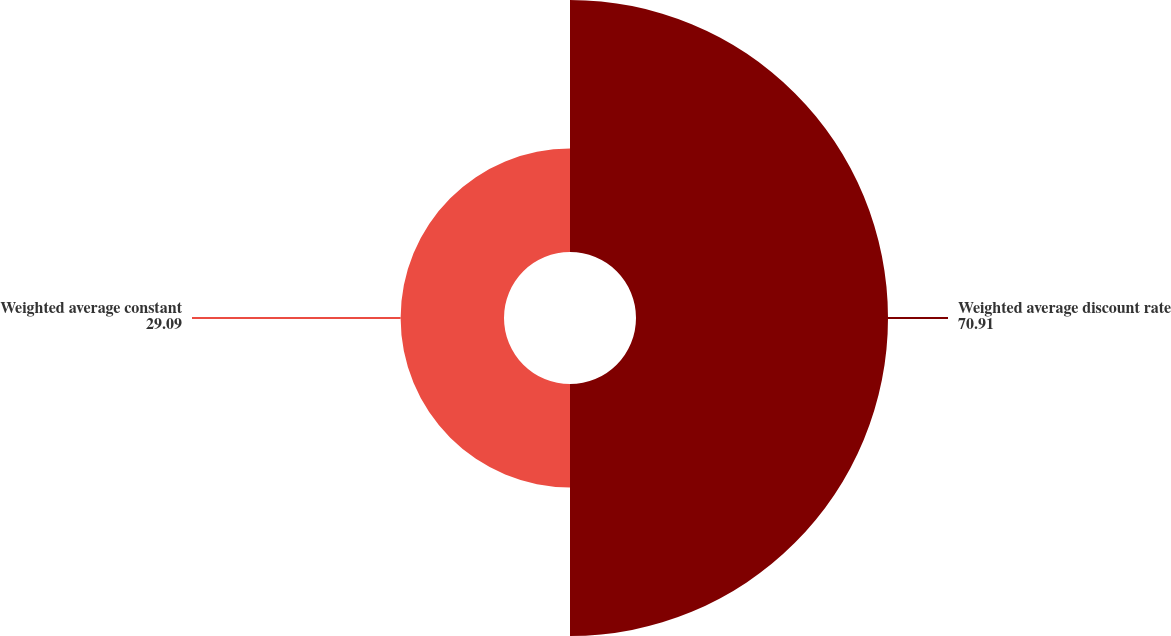<chart> <loc_0><loc_0><loc_500><loc_500><pie_chart><fcel>Weighted average discount rate<fcel>Weighted average constant<nl><fcel>70.91%<fcel>29.09%<nl></chart> 